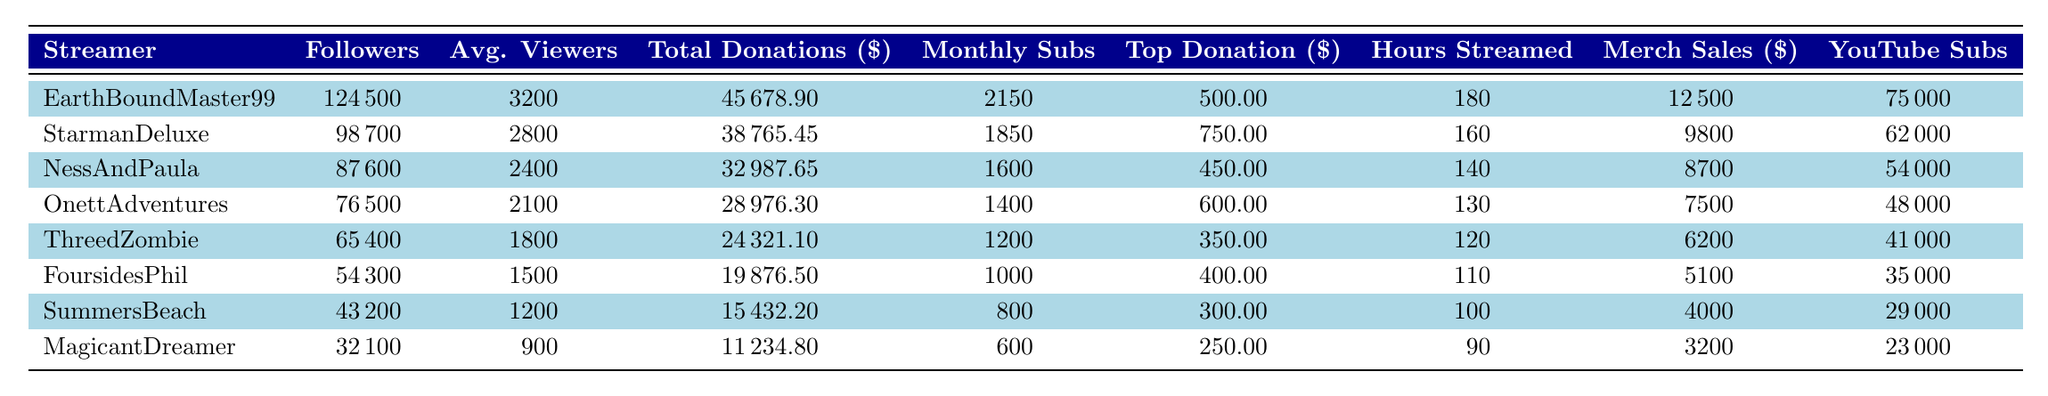What is the total amount of donations received by EarthBoundMaster99? EarthBoundMaster99 has total donations listed as 45678.90 in the table.
Answer: 45678.90 Which streamer has the highest average viewers? By reviewing the average viewers listed, EarthBoundMaster99 has 3200 average viewers, which is higher than all the others.
Answer: EarthBoundMaster99 What is the total number of hours streamed by all the streamers? Summing the hours streamed: 180 + 160 + 140 + 130 + 120 + 110 + 100 + 90 = 1030.
Answer: 1030 Who has the highest top donation among the streamers? StarmanDeluxe has the highest top donation of 750.00, based on the data.
Answer: StarmanDeluxe Is the total donations for NessAndPaula less than the total donations for FoursidesPhil? NessAndPaula has total donations of 32987.65, while FoursidesPhil has 19876.50. Since 32987.65 > 19876.50, the statement is false.
Answer: No What is the difference between the total donations of EarthBoundMaster99 and ThreedZombie? Calculating the difference: 45678.90 (EarthBoundMaster99) - 24321.10 (ThreedZombie) = 21357.80.
Answer: 21357.80 What percentage of followers does OnettAdventures have compared to EarthBoundMaster99? To find the percentage, calculate (76500 / 124500) * 100 = 61.5%.
Answer: 61.5% Which streamer has the least total donations, and what is that amount? The least total donations are for MagicantDreamer, which amounts to 11234.80, according to the table.
Answer: MagicantDreamer, 11234.80 Calculate the average number of monthly subscriptions for the streamers listed. The total subscriptions add up to 2150 + 1850 + 1600 + 1400 + 1200 + 1000 + 800 + 600 = 10800. There are 8 streamers, so the average is 10800 / 8 = 1350.
Answer: 1350 Is the total merch sales for SummersBeach greater than that of NessAndPaula? SummersBeach has merch sales of 4000 while NessAndPaula has 8700. Since 4000 < 8700, the statement is false.
Answer: No 